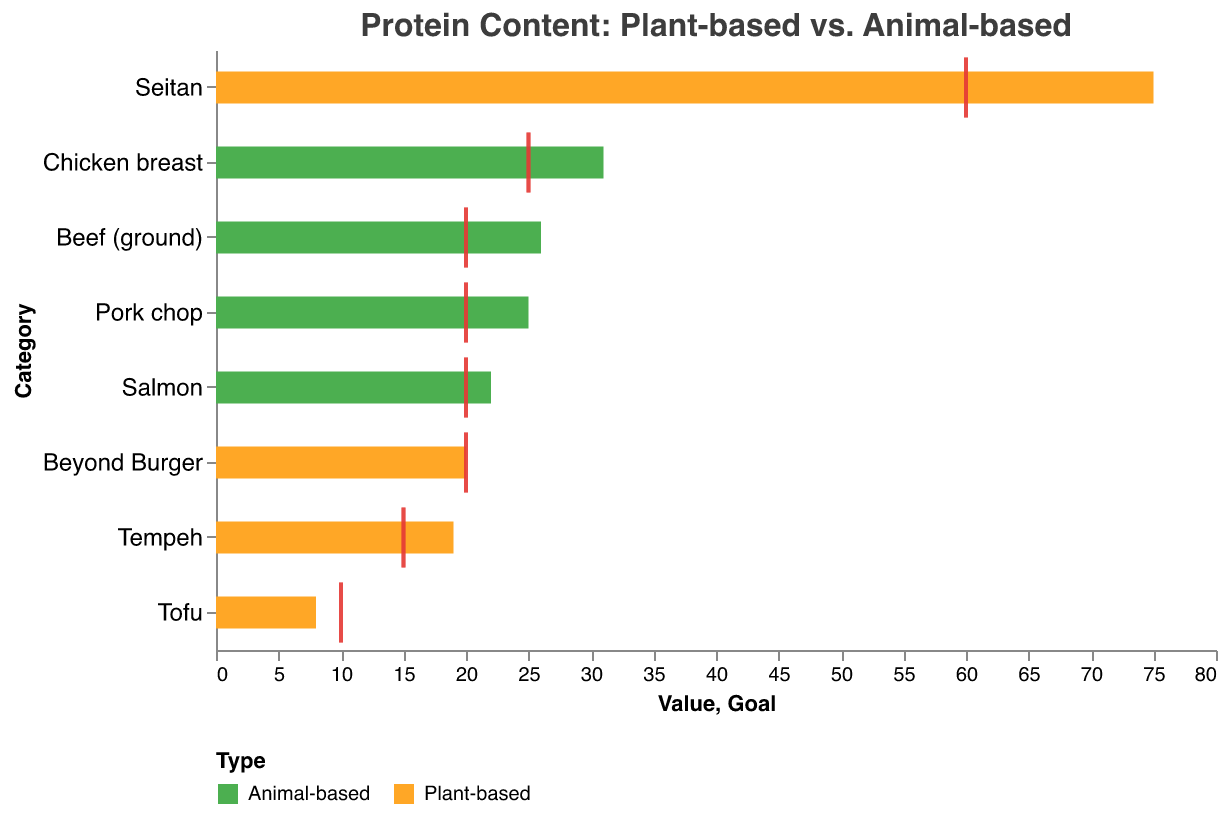How many categories are shown in the chart? The chart displays a list of items that include both plant-based and animal-based proteins. Counting these items gives the number of categories shown. There are 8 items listed in total.
Answer: 8 What is the title of the chart? The title is displayed at the top of the chart. It provides a summary of the content depicted. The title of the chart is "Protein Content: Plant-based vs. Animal-based."
Answer: Protein Content: Plant-based vs. Animal-based Which category exceeds the protein goal for the plant-based type? By comparing the plant-based values to their respective goals, we can see which protein quantities are greater than their goals. Seitan (75g) exceeds its goal (60g) for the plant-based type.
Answer: Seitan What is the protein goal for Beef (ground)? The goal for each category is marked by a tick. For Beef (ground), it's defined as a separate value of 20.
Answer: 20 Which has more protein, Chicken breast or Salmon? By comparing the protein values for Chicken breast (31g) and Salmon (22g), we determine that Chicken breast has more protein.
Answer: Chicken breast Does Tofu meet its protein goal? Tofu's plant-based protein value is 8g, while its goal is marked as 10g. Since 8g is less than 10g, Tofu does not meet its protein goal.
Answer: No What's the difference in protein content between Seitan and Tempeh for the plant-based values? Seitan has 75g of protein and Tempeh has 19g. The difference is calculated as 75 - 19.
Answer: 56 Which category of animal-based protein has the lowest goal? Comparing the goal values for all animal-based proteins, we see that Chicken breast (25), Beef (ground) (20), Pork chop (20), and Salmon (20) all have goals, with Salmon having the lowest at 20.
Answer: All (Beef (ground), Pork chop, Salmon) Does Beyond Burger meet its protein goal? The plant-based protein content of Beyond Burger is 20g, and its protein goal is also 20g, indicating it meets its goal.
Answer: Yes 